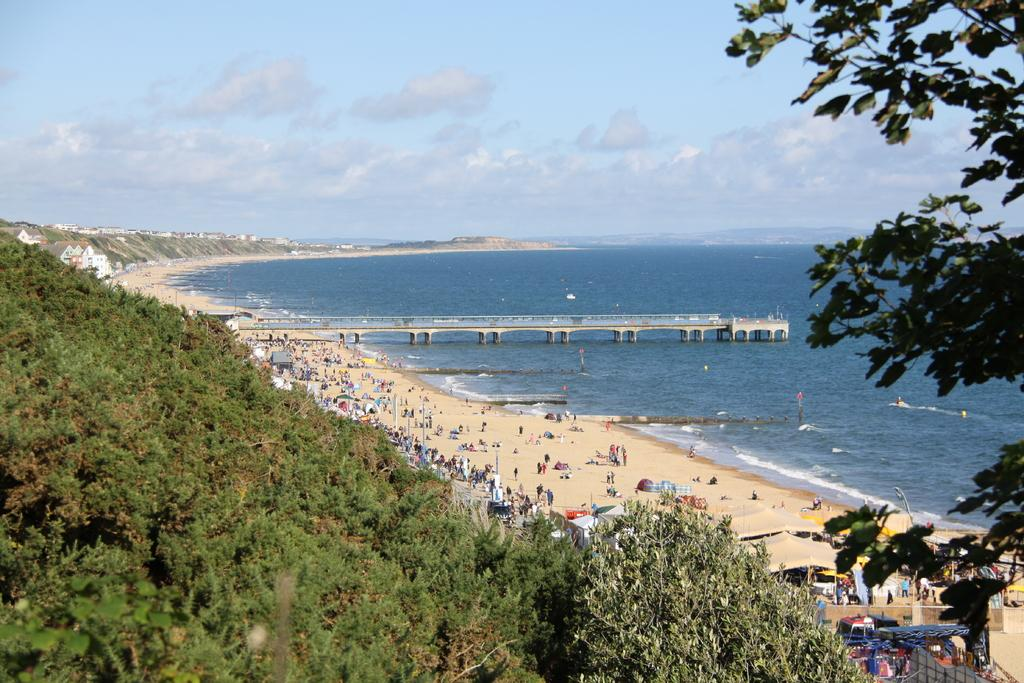What type of natural vegetation can be seen in the image? There are trees in the image. What type of temporary shelters are present in the image? There are tents in the image. Can you describe the people in the image? There are people in the image. What type of structure is present for crossing water in the image? There is a bridge in the image. What type of permanent structures can be seen in the image? There are houses in the image. What type of terrain is visible in the image? There is water visible in the image. What is the condition of the sky in the image? The sky is cloudy in the image. What type of vertical structures are present in the image? There are poles in the image. What type of metal is used to construct the clams in the image? There are no clams present in the image, and therefore no metal construction can be observed. What type of error is visible in the image? There is no error visible in the image; it appears to be a clear and accurate representation of the scene. 